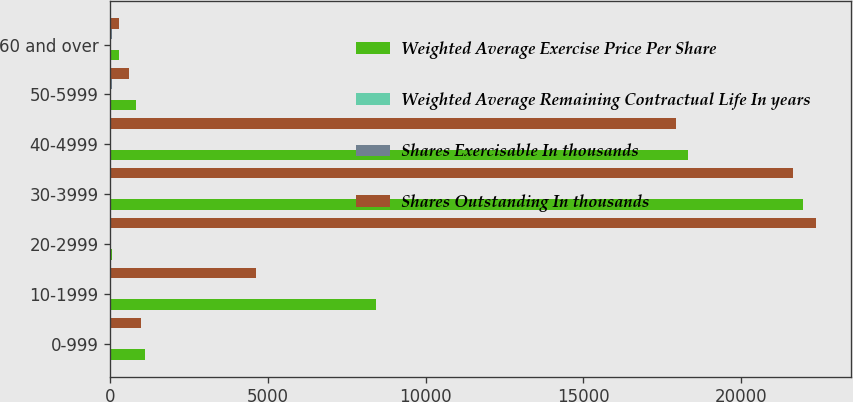<chart> <loc_0><loc_0><loc_500><loc_500><stacked_bar_chart><ecel><fcel>0-999<fcel>10-1999<fcel>20-2999<fcel>30-3999<fcel>40-4999<fcel>50-5999<fcel>60 and over<nl><fcel>Weighted Average Exercise Price Per Share<fcel>1097<fcel>8441<fcel>75<fcel>21962<fcel>18313<fcel>810<fcel>277<nl><fcel>Weighted Average Remaining Contractual Life In years<fcel>5.3<fcel>5.3<fcel>3.6<fcel>1.4<fcel>2.3<fcel>4.2<fcel>1.5<nl><fcel>Shares Exercisable In thousands<fcel>6<fcel>14<fcel>24<fcel>32<fcel>43<fcel>52<fcel>75<nl><fcel>Shares Outstanding In thousands<fcel>994<fcel>4622<fcel>22369<fcel>21645<fcel>17945<fcel>585<fcel>277<nl></chart> 